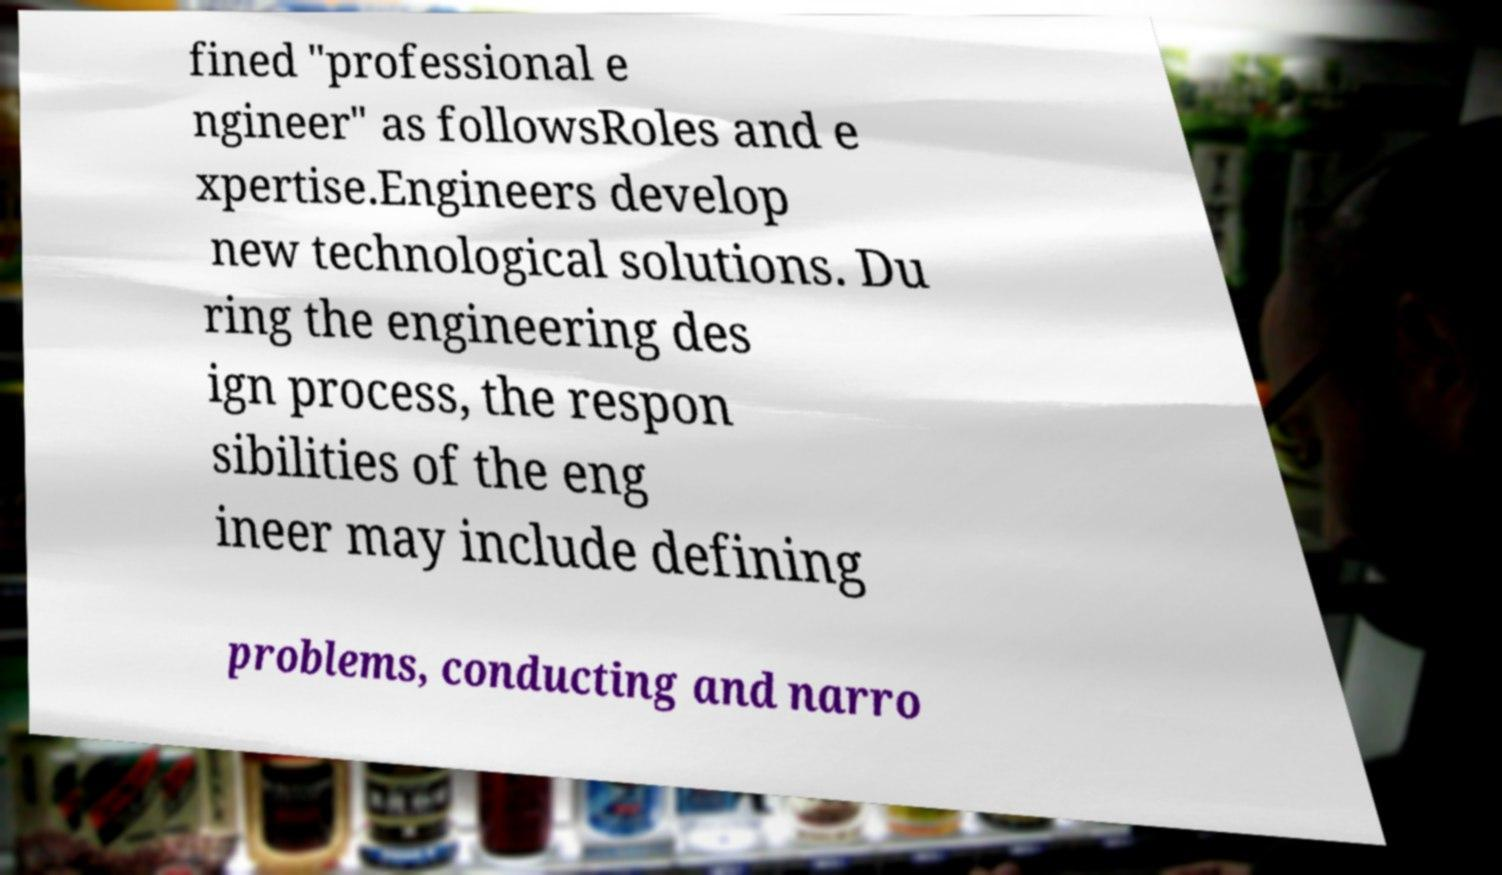Could you extract and type out the text from this image? fined "professional e ngineer" as followsRoles and e xpertise.Engineers develop new technological solutions. Du ring the engineering des ign process, the respon sibilities of the eng ineer may include defining problems, conducting and narro 